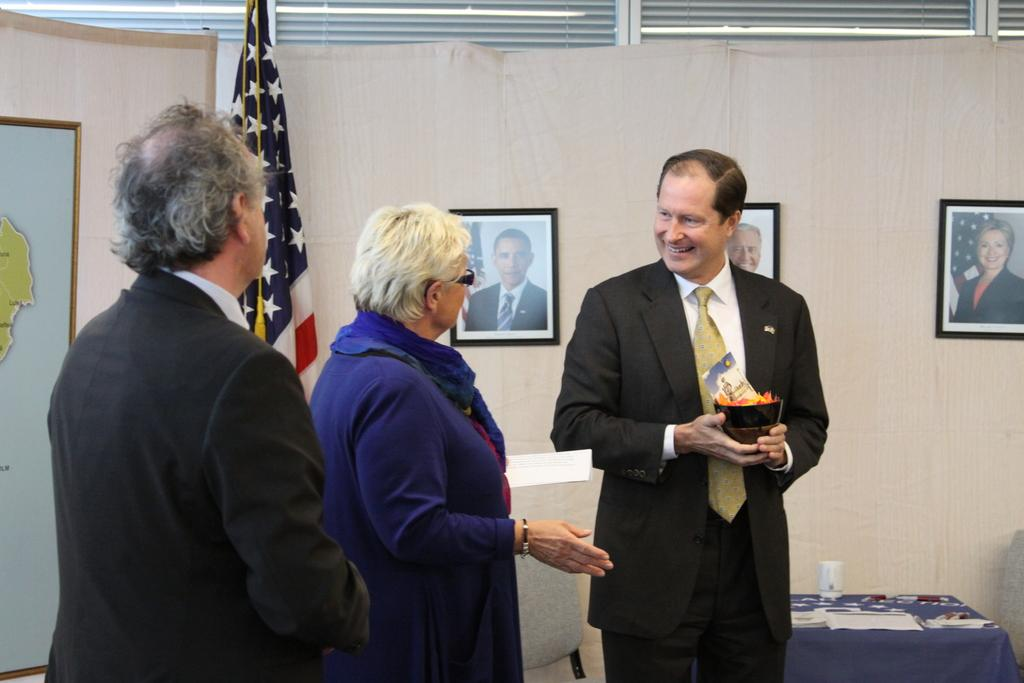What is the person holding in the image? The person is holding a bowl in the image. How many other people are present in the image? There are two other persons beside the person holding the bowl. What can be seen in the background of the image? There is a flag and a wall visible in the image. What objects are present on the table in the image? There is a cup and papers on the table in the image. What other structures or objects can be seen in the image? There are photo frames, a table, and a board in the image. What type of popcorn is being served in the image? There is no popcorn present in the image. How does the crow interact with the board in the image? There is no crow present in the image. 